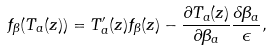Convert formula to latex. <formula><loc_0><loc_0><loc_500><loc_500>f _ { \beta } ( T _ { a } ( z ) ) = T _ { a } ^ { \prime } ( z ) f _ { \beta } ( z ) - \frac { \partial T _ { a } ( z ) } { \partial \beta _ { a } } \frac { \delta \beta _ { a } } { \epsilon } ,</formula> 